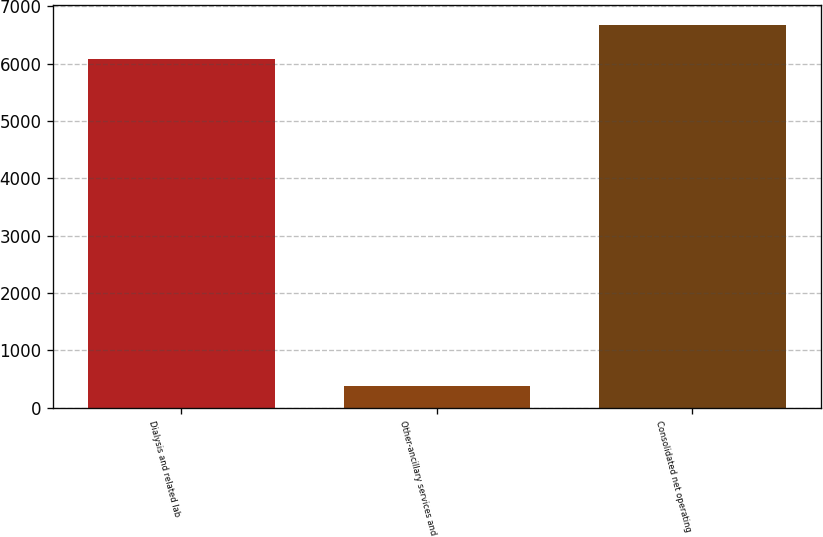Convert chart to OTSL. <chart><loc_0><loc_0><loc_500><loc_500><bar_chart><fcel>Dialysis and related lab<fcel>Other-ancillary services and<fcel>Consolidated net operating<nl><fcel>6073<fcel>374<fcel>6680.3<nl></chart> 